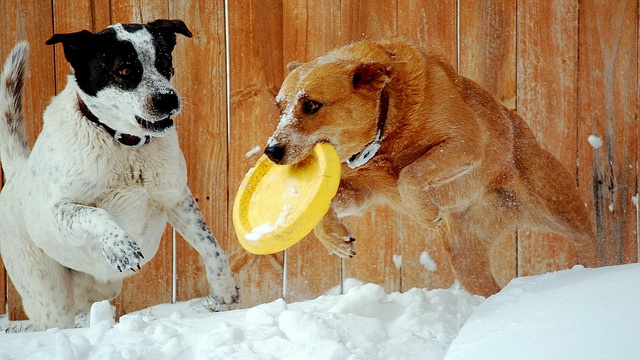Describe the objects in this image and their specific colors. I can see dog in brown, darkgray, lightgray, and black tones, dog in brown, gray, tan, and maroon tones, and frisbee in brown, khaki, and gold tones in this image. 